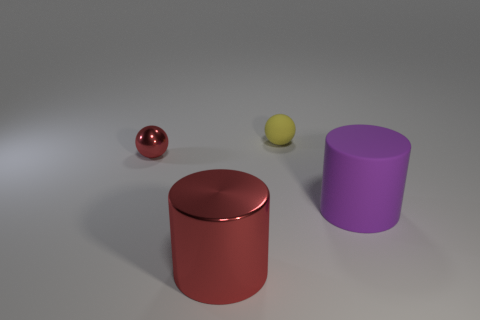Subtract all green cylinders. Subtract all brown blocks. How many cylinders are left? 2 Add 4 large purple rubber things. How many objects exist? 8 Add 1 red metallic cylinders. How many red metallic cylinders are left? 2 Add 3 large red metallic things. How many large red metallic things exist? 4 Subtract 0 brown cylinders. How many objects are left? 4 Subtract all large rubber balls. Subtract all tiny yellow rubber things. How many objects are left? 3 